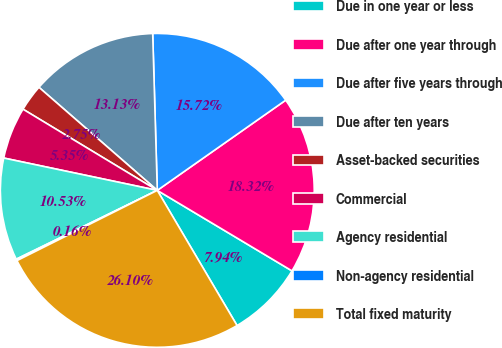Convert chart to OTSL. <chart><loc_0><loc_0><loc_500><loc_500><pie_chart><fcel>Due in one year or less<fcel>Due after one year through<fcel>Due after five years through<fcel>Due after ten years<fcel>Asset-backed securities<fcel>Commercial<fcel>Agency residential<fcel>Non-agency residential<fcel>Total fixed maturity<nl><fcel>7.94%<fcel>18.32%<fcel>15.72%<fcel>13.13%<fcel>2.75%<fcel>5.35%<fcel>10.53%<fcel>0.16%<fcel>26.1%<nl></chart> 